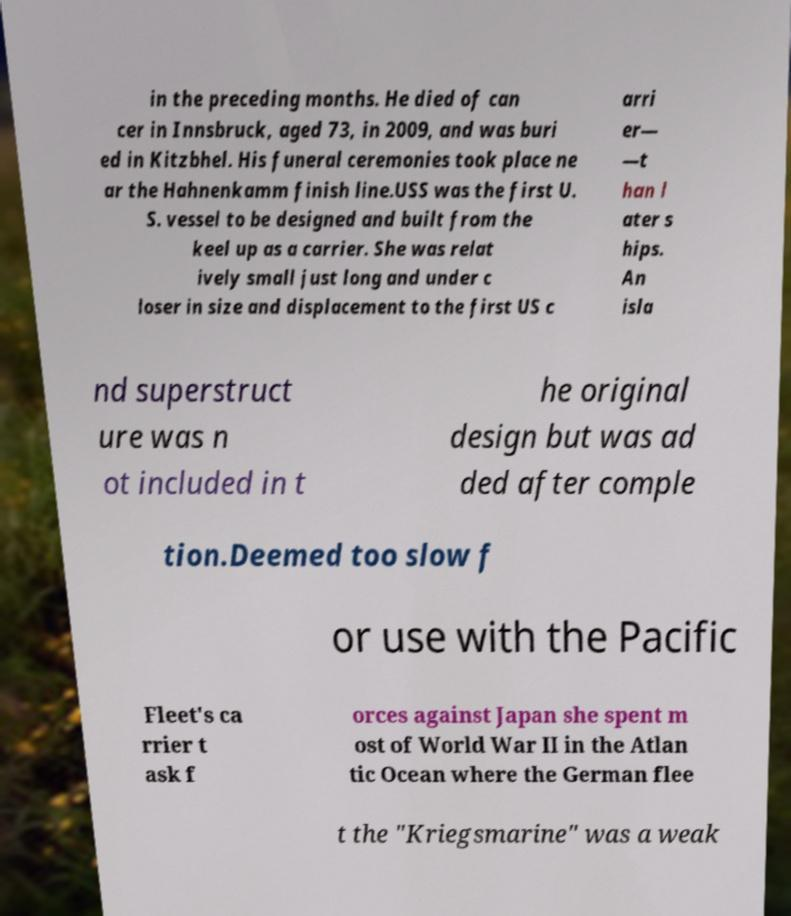Can you accurately transcribe the text from the provided image for me? in the preceding months. He died of can cer in Innsbruck, aged 73, in 2009, and was buri ed in Kitzbhel. His funeral ceremonies took place ne ar the Hahnenkamm finish line.USS was the first U. S. vessel to be designed and built from the keel up as a carrier. She was relat ively small just long and under c loser in size and displacement to the first US c arri er— —t han l ater s hips. An isla nd superstruct ure was n ot included in t he original design but was ad ded after comple tion.Deemed too slow f or use with the Pacific Fleet's ca rrier t ask f orces against Japan she spent m ost of World War II in the Atlan tic Ocean where the German flee t the "Kriegsmarine" was a weak 